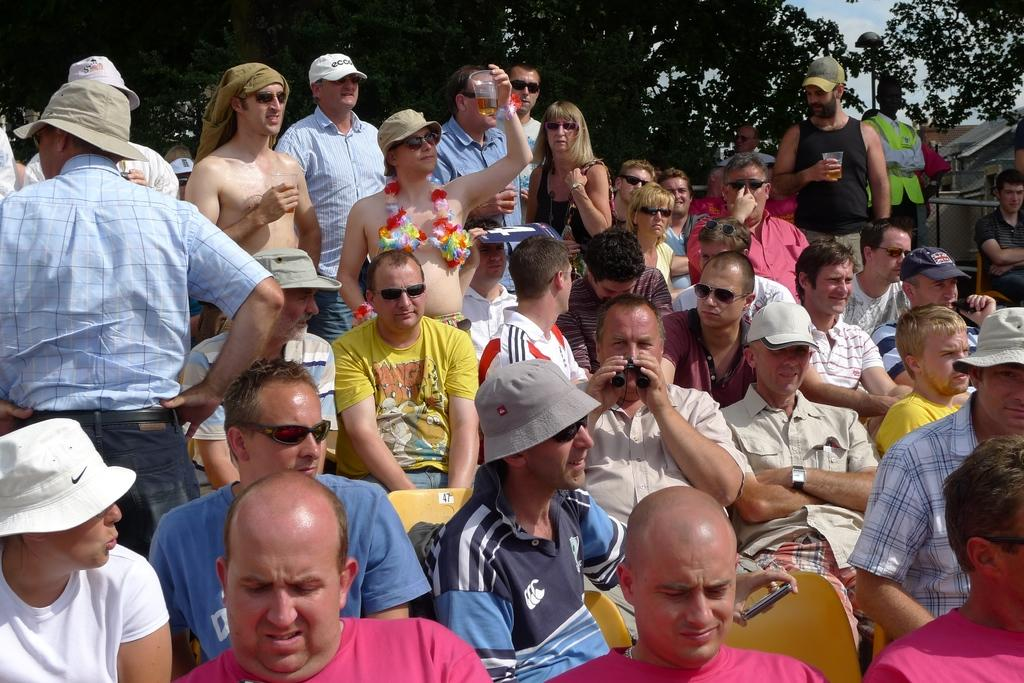What are the people in the image doing? There are people sitting on chairs and standing in the image. Can you describe the background of the image? There are trees in the background of the image. What is the smell of the image? Images do not have a smell, as they are visual representations. 